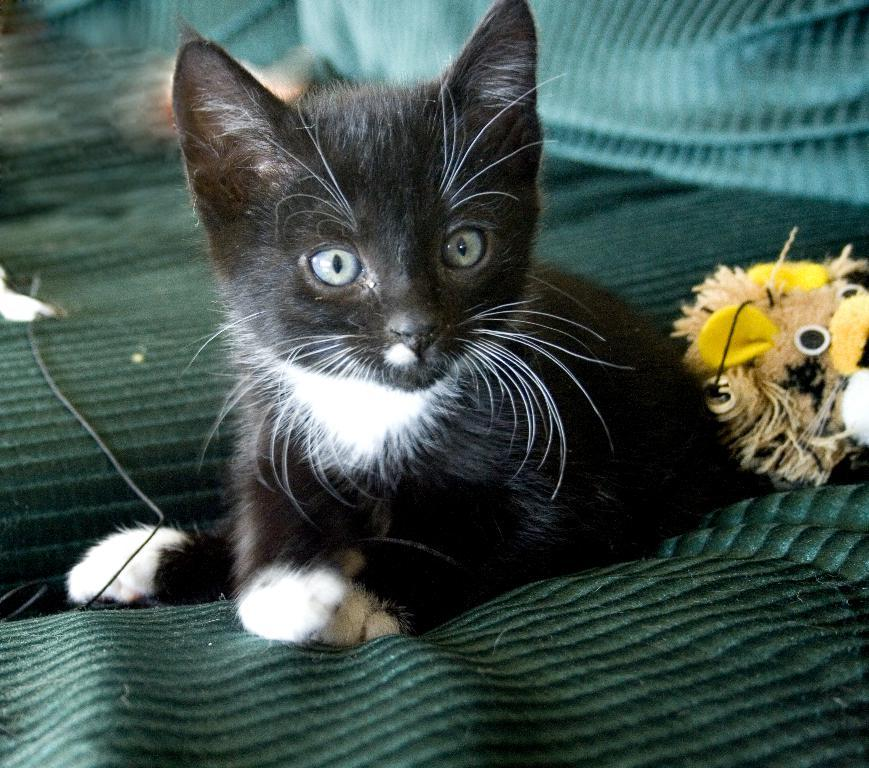What type of animal is in the image? There is a black cat in the image. Where is the cat located? The cat is on the bed or sofa. What is the color of the cat? The cat is green in color. What other object is near the cat? There is a stuffed toy beside the cat. What can be seen in the background of the image? There are green-colored pillows in the background. What type of poison is the cat using to attack the stuffed toy? There is no indication in the image that the cat is using poison or attacking the stuffed toy. 